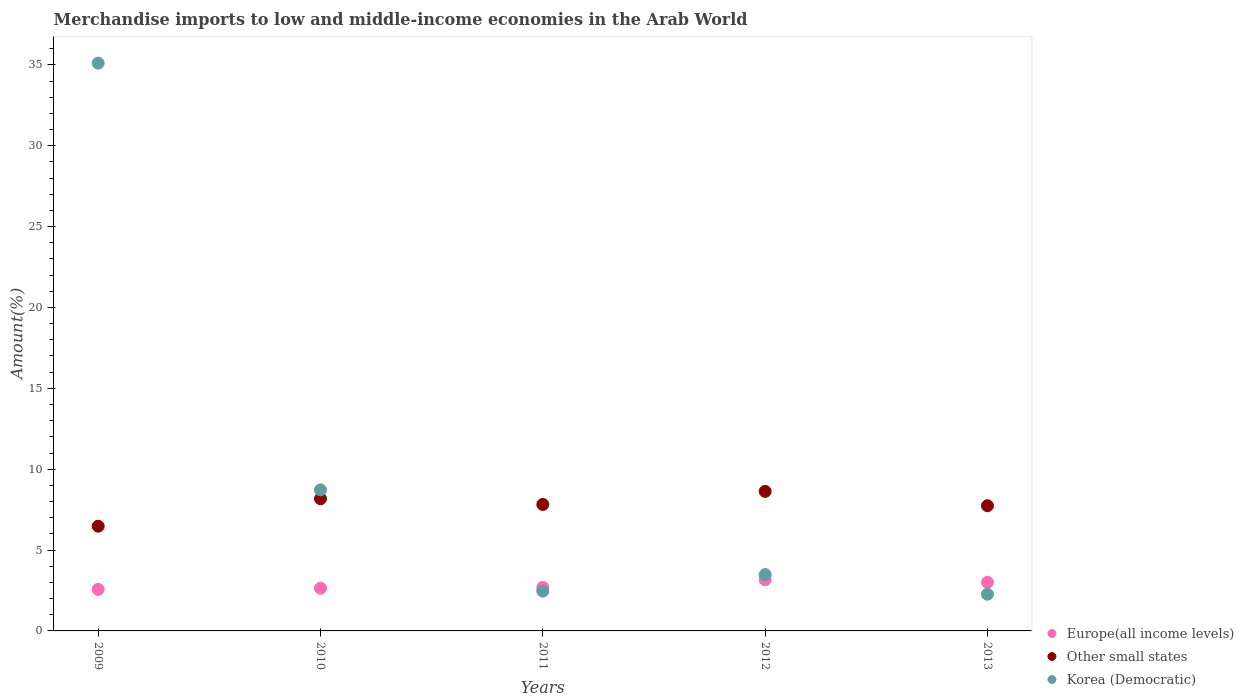What is the percentage of amount earned from merchandise imports in Europe(all income levels) in 2012?
Offer a very short reply. 3.17. Across all years, what is the maximum percentage of amount earned from merchandise imports in Other small states?
Keep it short and to the point. 8.63. Across all years, what is the minimum percentage of amount earned from merchandise imports in Korea (Democratic)?
Your response must be concise. 2.27. In which year was the percentage of amount earned from merchandise imports in Europe(all income levels) minimum?
Offer a very short reply. 2009. What is the total percentage of amount earned from merchandise imports in Other small states in the graph?
Offer a terse response. 38.84. What is the difference between the percentage of amount earned from merchandise imports in Korea (Democratic) in 2011 and that in 2013?
Keep it short and to the point. 0.19. What is the difference between the percentage of amount earned from merchandise imports in Korea (Democratic) in 2012 and the percentage of amount earned from merchandise imports in Europe(all income levels) in 2010?
Keep it short and to the point. 0.84. What is the average percentage of amount earned from merchandise imports in Europe(all income levels) per year?
Keep it short and to the point. 2.82. In the year 2009, what is the difference between the percentage of amount earned from merchandise imports in Other small states and percentage of amount earned from merchandise imports in Europe(all income levels)?
Make the answer very short. 3.9. In how many years, is the percentage of amount earned from merchandise imports in Other small states greater than 12 %?
Ensure brevity in your answer.  0. What is the ratio of the percentage of amount earned from merchandise imports in Europe(all income levels) in 2009 to that in 2010?
Your answer should be compact. 0.97. What is the difference between the highest and the second highest percentage of amount earned from merchandise imports in Other small states?
Make the answer very short. 0.45. What is the difference between the highest and the lowest percentage of amount earned from merchandise imports in Europe(all income levels)?
Ensure brevity in your answer.  0.6. In how many years, is the percentage of amount earned from merchandise imports in Korea (Democratic) greater than the average percentage of amount earned from merchandise imports in Korea (Democratic) taken over all years?
Provide a succinct answer. 1. Is the sum of the percentage of amount earned from merchandise imports in Other small states in 2009 and 2011 greater than the maximum percentage of amount earned from merchandise imports in Korea (Democratic) across all years?
Keep it short and to the point. No. Is the percentage of amount earned from merchandise imports in Europe(all income levels) strictly less than the percentage of amount earned from merchandise imports in Other small states over the years?
Offer a terse response. Yes. How many years are there in the graph?
Your answer should be very brief. 5. What is the difference between two consecutive major ticks on the Y-axis?
Your answer should be very brief. 5. Are the values on the major ticks of Y-axis written in scientific E-notation?
Your answer should be compact. No. Does the graph contain any zero values?
Keep it short and to the point. No. Does the graph contain grids?
Offer a very short reply. No. What is the title of the graph?
Your answer should be compact. Merchandise imports to low and middle-income economies in the Arab World. Does "Russian Federation" appear as one of the legend labels in the graph?
Your response must be concise. No. What is the label or title of the X-axis?
Provide a succinct answer. Years. What is the label or title of the Y-axis?
Your answer should be very brief. Amount(%). What is the Amount(%) of Europe(all income levels) in 2009?
Your response must be concise. 2.57. What is the Amount(%) of Other small states in 2009?
Your answer should be very brief. 6.47. What is the Amount(%) in Korea (Democratic) in 2009?
Your answer should be compact. 35.11. What is the Amount(%) of Europe(all income levels) in 2010?
Provide a short and direct response. 2.64. What is the Amount(%) of Other small states in 2010?
Offer a very short reply. 8.17. What is the Amount(%) in Korea (Democratic) in 2010?
Offer a terse response. 8.72. What is the Amount(%) of Europe(all income levels) in 2011?
Provide a succinct answer. 2.7. What is the Amount(%) in Other small states in 2011?
Your answer should be compact. 7.82. What is the Amount(%) in Korea (Democratic) in 2011?
Offer a terse response. 2.46. What is the Amount(%) in Europe(all income levels) in 2012?
Your answer should be very brief. 3.17. What is the Amount(%) of Other small states in 2012?
Your answer should be very brief. 8.63. What is the Amount(%) in Korea (Democratic) in 2012?
Your response must be concise. 3.48. What is the Amount(%) of Europe(all income levels) in 2013?
Your response must be concise. 3.01. What is the Amount(%) of Other small states in 2013?
Your answer should be very brief. 7.74. What is the Amount(%) of Korea (Democratic) in 2013?
Your answer should be compact. 2.27. Across all years, what is the maximum Amount(%) in Europe(all income levels)?
Ensure brevity in your answer.  3.17. Across all years, what is the maximum Amount(%) in Other small states?
Ensure brevity in your answer.  8.63. Across all years, what is the maximum Amount(%) in Korea (Democratic)?
Ensure brevity in your answer.  35.11. Across all years, what is the minimum Amount(%) of Europe(all income levels)?
Keep it short and to the point. 2.57. Across all years, what is the minimum Amount(%) of Other small states?
Offer a terse response. 6.47. Across all years, what is the minimum Amount(%) in Korea (Democratic)?
Your response must be concise. 2.27. What is the total Amount(%) in Europe(all income levels) in the graph?
Offer a very short reply. 14.08. What is the total Amount(%) in Other small states in the graph?
Make the answer very short. 38.84. What is the total Amount(%) of Korea (Democratic) in the graph?
Provide a short and direct response. 52.05. What is the difference between the Amount(%) of Europe(all income levels) in 2009 and that in 2010?
Your answer should be very brief. -0.07. What is the difference between the Amount(%) of Other small states in 2009 and that in 2010?
Your answer should be very brief. -1.7. What is the difference between the Amount(%) of Korea (Democratic) in 2009 and that in 2010?
Your answer should be very brief. 26.38. What is the difference between the Amount(%) of Europe(all income levels) in 2009 and that in 2011?
Keep it short and to the point. -0.13. What is the difference between the Amount(%) in Other small states in 2009 and that in 2011?
Make the answer very short. -1.35. What is the difference between the Amount(%) in Korea (Democratic) in 2009 and that in 2011?
Make the answer very short. 32.65. What is the difference between the Amount(%) of Europe(all income levels) in 2009 and that in 2012?
Your answer should be compact. -0.6. What is the difference between the Amount(%) in Other small states in 2009 and that in 2012?
Your answer should be very brief. -2.15. What is the difference between the Amount(%) in Korea (Democratic) in 2009 and that in 2012?
Your response must be concise. 31.63. What is the difference between the Amount(%) of Europe(all income levels) in 2009 and that in 2013?
Make the answer very short. -0.44. What is the difference between the Amount(%) of Other small states in 2009 and that in 2013?
Your answer should be compact. -1.27. What is the difference between the Amount(%) of Korea (Democratic) in 2009 and that in 2013?
Provide a short and direct response. 32.84. What is the difference between the Amount(%) in Europe(all income levels) in 2010 and that in 2011?
Provide a short and direct response. -0.05. What is the difference between the Amount(%) of Other small states in 2010 and that in 2011?
Offer a terse response. 0.35. What is the difference between the Amount(%) of Korea (Democratic) in 2010 and that in 2011?
Your answer should be very brief. 6.26. What is the difference between the Amount(%) of Europe(all income levels) in 2010 and that in 2012?
Your answer should be compact. -0.53. What is the difference between the Amount(%) of Other small states in 2010 and that in 2012?
Offer a terse response. -0.45. What is the difference between the Amount(%) of Korea (Democratic) in 2010 and that in 2012?
Make the answer very short. 5.24. What is the difference between the Amount(%) of Europe(all income levels) in 2010 and that in 2013?
Ensure brevity in your answer.  -0.36. What is the difference between the Amount(%) in Other small states in 2010 and that in 2013?
Provide a succinct answer. 0.43. What is the difference between the Amount(%) of Korea (Democratic) in 2010 and that in 2013?
Provide a succinct answer. 6.46. What is the difference between the Amount(%) of Europe(all income levels) in 2011 and that in 2012?
Offer a very short reply. -0.47. What is the difference between the Amount(%) of Other small states in 2011 and that in 2012?
Give a very brief answer. -0.81. What is the difference between the Amount(%) in Korea (Democratic) in 2011 and that in 2012?
Give a very brief answer. -1.02. What is the difference between the Amount(%) of Europe(all income levels) in 2011 and that in 2013?
Your response must be concise. -0.31. What is the difference between the Amount(%) in Other small states in 2011 and that in 2013?
Offer a terse response. 0.08. What is the difference between the Amount(%) of Korea (Democratic) in 2011 and that in 2013?
Give a very brief answer. 0.19. What is the difference between the Amount(%) in Europe(all income levels) in 2012 and that in 2013?
Your response must be concise. 0.16. What is the difference between the Amount(%) in Other small states in 2012 and that in 2013?
Ensure brevity in your answer.  0.89. What is the difference between the Amount(%) of Korea (Democratic) in 2012 and that in 2013?
Your answer should be very brief. 1.21. What is the difference between the Amount(%) of Europe(all income levels) in 2009 and the Amount(%) of Other small states in 2010?
Provide a short and direct response. -5.6. What is the difference between the Amount(%) in Europe(all income levels) in 2009 and the Amount(%) in Korea (Democratic) in 2010?
Provide a succinct answer. -6.15. What is the difference between the Amount(%) in Other small states in 2009 and the Amount(%) in Korea (Democratic) in 2010?
Offer a very short reply. -2.25. What is the difference between the Amount(%) of Europe(all income levels) in 2009 and the Amount(%) of Other small states in 2011?
Keep it short and to the point. -5.25. What is the difference between the Amount(%) in Europe(all income levels) in 2009 and the Amount(%) in Korea (Democratic) in 2011?
Offer a terse response. 0.11. What is the difference between the Amount(%) of Other small states in 2009 and the Amount(%) of Korea (Democratic) in 2011?
Make the answer very short. 4.01. What is the difference between the Amount(%) of Europe(all income levels) in 2009 and the Amount(%) of Other small states in 2012?
Provide a succinct answer. -6.06. What is the difference between the Amount(%) in Europe(all income levels) in 2009 and the Amount(%) in Korea (Democratic) in 2012?
Offer a very short reply. -0.91. What is the difference between the Amount(%) of Other small states in 2009 and the Amount(%) of Korea (Democratic) in 2012?
Provide a short and direct response. 2.99. What is the difference between the Amount(%) of Europe(all income levels) in 2009 and the Amount(%) of Other small states in 2013?
Make the answer very short. -5.17. What is the difference between the Amount(%) of Europe(all income levels) in 2009 and the Amount(%) of Korea (Democratic) in 2013?
Give a very brief answer. 0.3. What is the difference between the Amount(%) of Other small states in 2009 and the Amount(%) of Korea (Democratic) in 2013?
Your response must be concise. 4.2. What is the difference between the Amount(%) in Europe(all income levels) in 2010 and the Amount(%) in Other small states in 2011?
Your answer should be very brief. -5.18. What is the difference between the Amount(%) of Europe(all income levels) in 2010 and the Amount(%) of Korea (Democratic) in 2011?
Your answer should be compact. 0.18. What is the difference between the Amount(%) in Other small states in 2010 and the Amount(%) in Korea (Democratic) in 2011?
Give a very brief answer. 5.71. What is the difference between the Amount(%) of Europe(all income levels) in 2010 and the Amount(%) of Other small states in 2012?
Give a very brief answer. -5.99. What is the difference between the Amount(%) of Europe(all income levels) in 2010 and the Amount(%) of Korea (Democratic) in 2012?
Your response must be concise. -0.84. What is the difference between the Amount(%) of Other small states in 2010 and the Amount(%) of Korea (Democratic) in 2012?
Provide a short and direct response. 4.69. What is the difference between the Amount(%) of Europe(all income levels) in 2010 and the Amount(%) of Other small states in 2013?
Give a very brief answer. -5.1. What is the difference between the Amount(%) in Europe(all income levels) in 2010 and the Amount(%) in Korea (Democratic) in 2013?
Keep it short and to the point. 0.37. What is the difference between the Amount(%) of Other small states in 2010 and the Amount(%) of Korea (Democratic) in 2013?
Your response must be concise. 5.9. What is the difference between the Amount(%) of Europe(all income levels) in 2011 and the Amount(%) of Other small states in 2012?
Provide a short and direct response. -5.93. What is the difference between the Amount(%) in Europe(all income levels) in 2011 and the Amount(%) in Korea (Democratic) in 2012?
Keep it short and to the point. -0.79. What is the difference between the Amount(%) of Other small states in 2011 and the Amount(%) of Korea (Democratic) in 2012?
Make the answer very short. 4.34. What is the difference between the Amount(%) in Europe(all income levels) in 2011 and the Amount(%) in Other small states in 2013?
Make the answer very short. -5.05. What is the difference between the Amount(%) of Europe(all income levels) in 2011 and the Amount(%) of Korea (Democratic) in 2013?
Make the answer very short. 0.43. What is the difference between the Amount(%) in Other small states in 2011 and the Amount(%) in Korea (Democratic) in 2013?
Your answer should be very brief. 5.55. What is the difference between the Amount(%) of Europe(all income levels) in 2012 and the Amount(%) of Other small states in 2013?
Provide a short and direct response. -4.57. What is the difference between the Amount(%) of Europe(all income levels) in 2012 and the Amount(%) of Korea (Democratic) in 2013?
Your answer should be compact. 0.9. What is the difference between the Amount(%) in Other small states in 2012 and the Amount(%) in Korea (Democratic) in 2013?
Ensure brevity in your answer.  6.36. What is the average Amount(%) of Europe(all income levels) per year?
Provide a short and direct response. 2.82. What is the average Amount(%) in Other small states per year?
Keep it short and to the point. 7.77. What is the average Amount(%) of Korea (Democratic) per year?
Give a very brief answer. 10.41. In the year 2009, what is the difference between the Amount(%) of Europe(all income levels) and Amount(%) of Other small states?
Keep it short and to the point. -3.9. In the year 2009, what is the difference between the Amount(%) of Europe(all income levels) and Amount(%) of Korea (Democratic)?
Your response must be concise. -32.54. In the year 2009, what is the difference between the Amount(%) in Other small states and Amount(%) in Korea (Democratic)?
Your response must be concise. -28.64. In the year 2010, what is the difference between the Amount(%) of Europe(all income levels) and Amount(%) of Other small states?
Provide a succinct answer. -5.53. In the year 2010, what is the difference between the Amount(%) of Europe(all income levels) and Amount(%) of Korea (Democratic)?
Make the answer very short. -6.08. In the year 2010, what is the difference between the Amount(%) in Other small states and Amount(%) in Korea (Democratic)?
Offer a very short reply. -0.55. In the year 2011, what is the difference between the Amount(%) in Europe(all income levels) and Amount(%) in Other small states?
Offer a very short reply. -5.12. In the year 2011, what is the difference between the Amount(%) in Europe(all income levels) and Amount(%) in Korea (Democratic)?
Offer a very short reply. 0.23. In the year 2011, what is the difference between the Amount(%) in Other small states and Amount(%) in Korea (Democratic)?
Your answer should be very brief. 5.36. In the year 2012, what is the difference between the Amount(%) of Europe(all income levels) and Amount(%) of Other small states?
Your answer should be very brief. -5.46. In the year 2012, what is the difference between the Amount(%) of Europe(all income levels) and Amount(%) of Korea (Democratic)?
Make the answer very short. -0.31. In the year 2012, what is the difference between the Amount(%) in Other small states and Amount(%) in Korea (Democratic)?
Make the answer very short. 5.15. In the year 2013, what is the difference between the Amount(%) of Europe(all income levels) and Amount(%) of Other small states?
Keep it short and to the point. -4.74. In the year 2013, what is the difference between the Amount(%) of Europe(all income levels) and Amount(%) of Korea (Democratic)?
Offer a terse response. 0.74. In the year 2013, what is the difference between the Amount(%) of Other small states and Amount(%) of Korea (Democratic)?
Provide a short and direct response. 5.47. What is the ratio of the Amount(%) of Europe(all income levels) in 2009 to that in 2010?
Offer a terse response. 0.97. What is the ratio of the Amount(%) in Other small states in 2009 to that in 2010?
Offer a terse response. 0.79. What is the ratio of the Amount(%) in Korea (Democratic) in 2009 to that in 2010?
Your answer should be compact. 4.02. What is the ratio of the Amount(%) of Europe(all income levels) in 2009 to that in 2011?
Your response must be concise. 0.95. What is the ratio of the Amount(%) of Other small states in 2009 to that in 2011?
Provide a succinct answer. 0.83. What is the ratio of the Amount(%) of Korea (Democratic) in 2009 to that in 2011?
Offer a very short reply. 14.27. What is the ratio of the Amount(%) in Europe(all income levels) in 2009 to that in 2012?
Provide a succinct answer. 0.81. What is the ratio of the Amount(%) in Other small states in 2009 to that in 2012?
Your answer should be compact. 0.75. What is the ratio of the Amount(%) of Korea (Democratic) in 2009 to that in 2012?
Make the answer very short. 10.08. What is the ratio of the Amount(%) in Europe(all income levels) in 2009 to that in 2013?
Your answer should be compact. 0.85. What is the ratio of the Amount(%) of Other small states in 2009 to that in 2013?
Ensure brevity in your answer.  0.84. What is the ratio of the Amount(%) of Korea (Democratic) in 2009 to that in 2013?
Offer a terse response. 15.47. What is the ratio of the Amount(%) of Europe(all income levels) in 2010 to that in 2011?
Provide a short and direct response. 0.98. What is the ratio of the Amount(%) in Other small states in 2010 to that in 2011?
Your response must be concise. 1.05. What is the ratio of the Amount(%) of Korea (Democratic) in 2010 to that in 2011?
Make the answer very short. 3.55. What is the ratio of the Amount(%) in Europe(all income levels) in 2010 to that in 2012?
Your answer should be compact. 0.83. What is the ratio of the Amount(%) of Other small states in 2010 to that in 2012?
Offer a very short reply. 0.95. What is the ratio of the Amount(%) of Korea (Democratic) in 2010 to that in 2012?
Your answer should be compact. 2.51. What is the ratio of the Amount(%) of Europe(all income levels) in 2010 to that in 2013?
Your answer should be compact. 0.88. What is the ratio of the Amount(%) of Other small states in 2010 to that in 2013?
Your answer should be very brief. 1.06. What is the ratio of the Amount(%) of Korea (Democratic) in 2010 to that in 2013?
Provide a succinct answer. 3.84. What is the ratio of the Amount(%) in Europe(all income levels) in 2011 to that in 2012?
Ensure brevity in your answer.  0.85. What is the ratio of the Amount(%) of Other small states in 2011 to that in 2012?
Ensure brevity in your answer.  0.91. What is the ratio of the Amount(%) of Korea (Democratic) in 2011 to that in 2012?
Offer a very short reply. 0.71. What is the ratio of the Amount(%) in Europe(all income levels) in 2011 to that in 2013?
Provide a short and direct response. 0.9. What is the ratio of the Amount(%) of Other small states in 2011 to that in 2013?
Your answer should be compact. 1.01. What is the ratio of the Amount(%) in Korea (Democratic) in 2011 to that in 2013?
Provide a short and direct response. 1.08. What is the ratio of the Amount(%) of Europe(all income levels) in 2012 to that in 2013?
Give a very brief answer. 1.05. What is the ratio of the Amount(%) of Other small states in 2012 to that in 2013?
Your answer should be compact. 1.11. What is the ratio of the Amount(%) of Korea (Democratic) in 2012 to that in 2013?
Your response must be concise. 1.53. What is the difference between the highest and the second highest Amount(%) of Europe(all income levels)?
Provide a short and direct response. 0.16. What is the difference between the highest and the second highest Amount(%) in Other small states?
Provide a succinct answer. 0.45. What is the difference between the highest and the second highest Amount(%) of Korea (Democratic)?
Make the answer very short. 26.38. What is the difference between the highest and the lowest Amount(%) in Europe(all income levels)?
Your answer should be compact. 0.6. What is the difference between the highest and the lowest Amount(%) in Other small states?
Give a very brief answer. 2.15. What is the difference between the highest and the lowest Amount(%) of Korea (Democratic)?
Give a very brief answer. 32.84. 